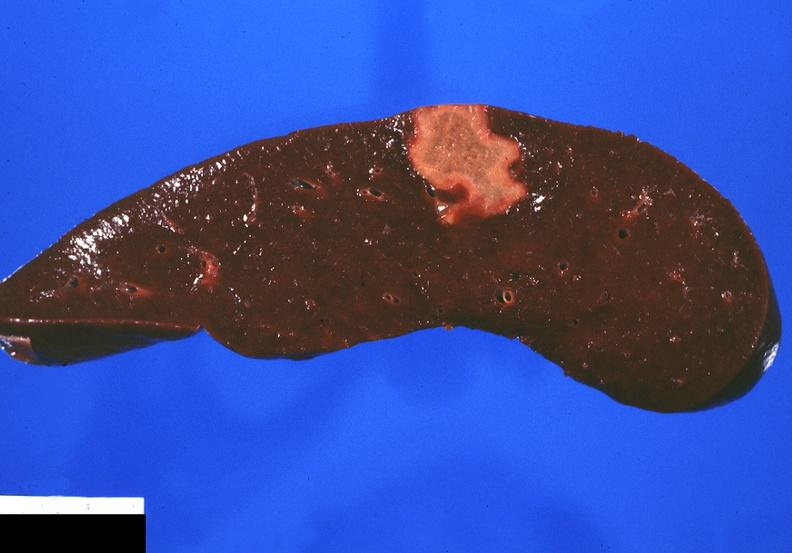what does this image show?
Answer the question using a single word or phrase. Splenic infarct 